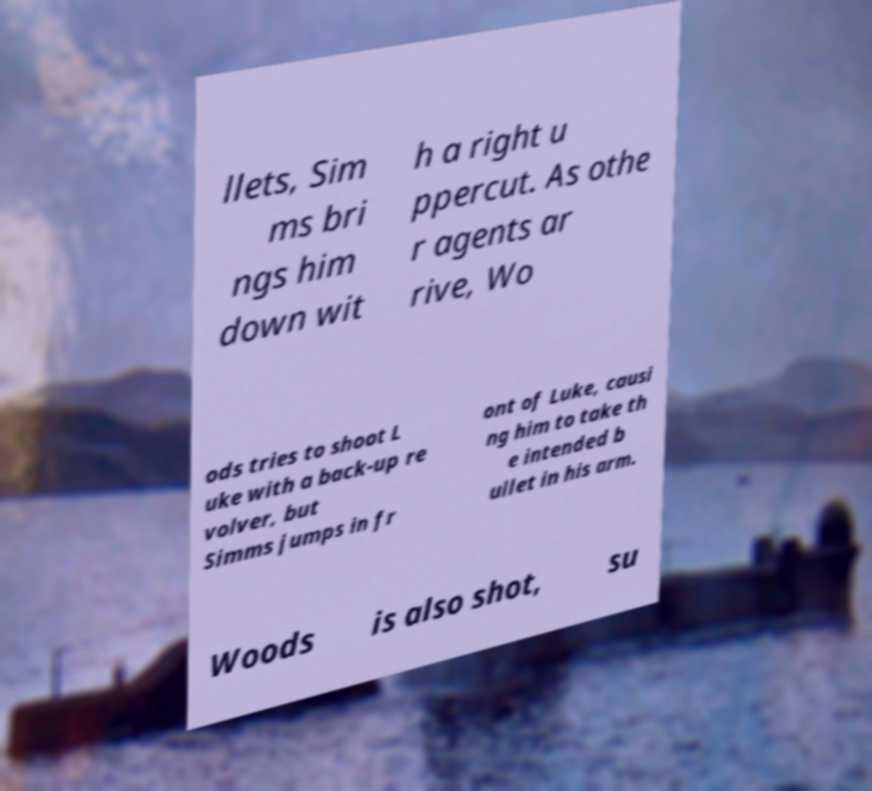Please identify and transcribe the text found in this image. llets, Sim ms bri ngs him down wit h a right u ppercut. As othe r agents ar rive, Wo ods tries to shoot L uke with a back-up re volver, but Simms jumps in fr ont of Luke, causi ng him to take th e intended b ullet in his arm. Woods is also shot, su 